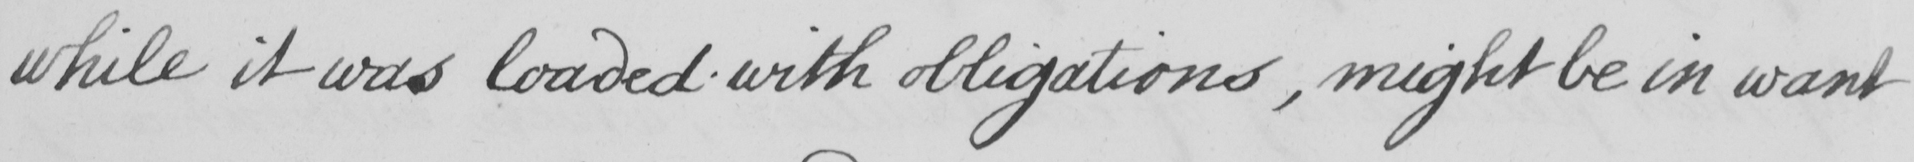Please provide the text content of this handwritten line. while it was loaded with obligations , might be in want 